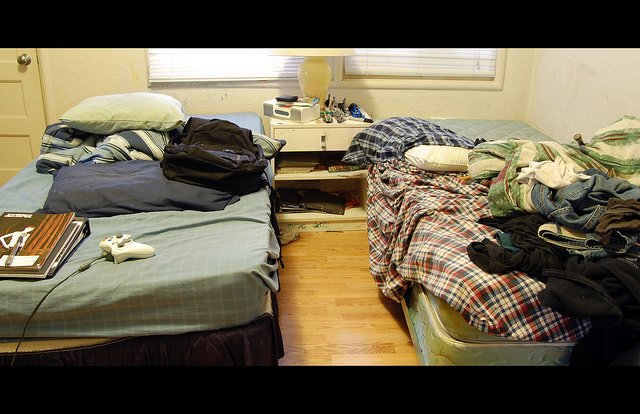<image>What kind of game controller is it? I'm not sure what kind of game controller it is. It could be an xbox or playstation controller. What kind of game controller is it? I don't know what kind of game controller it is. It can be xbox, playstation or gamecube. 